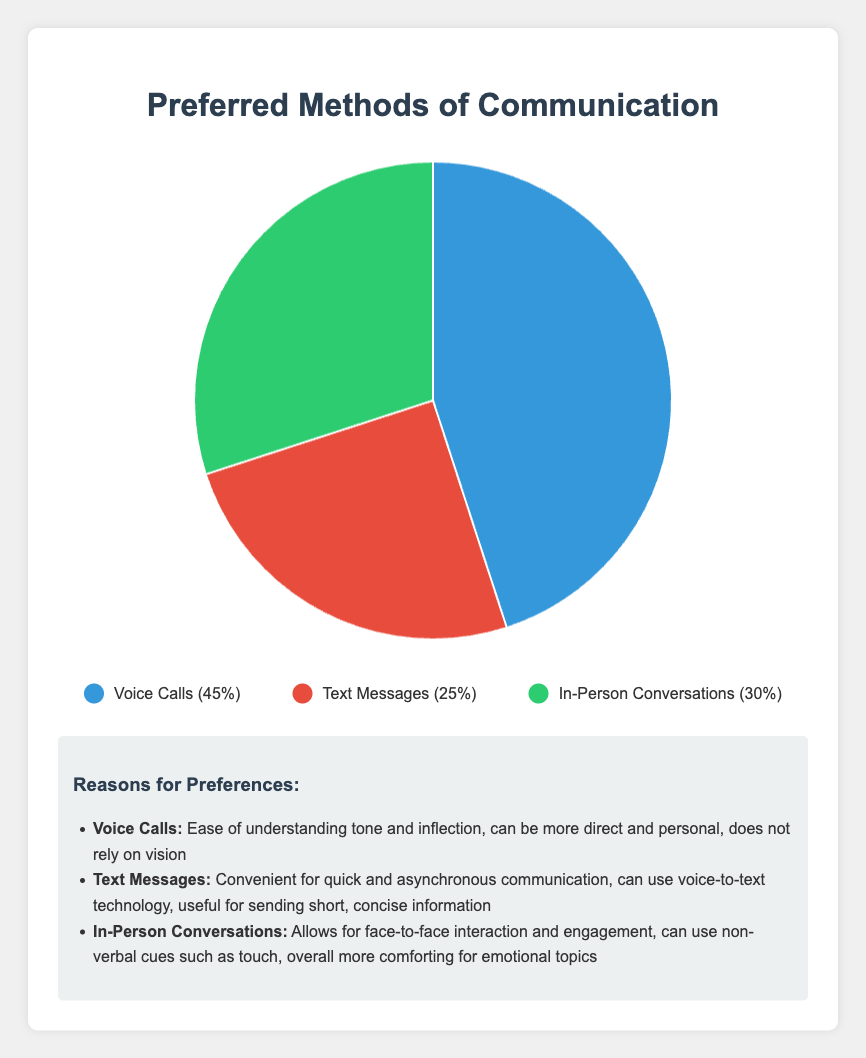What's the largest communication method visualized in the pie chart? The legend and the pie chart show that the method with the largest percentage is Voice Calls at 45%.
Answer: Voice Calls What percentage of people prefer Text Messages compared to those preferring In-Person Conversations? According to the pie chart, 25% prefer Text Messages and 30% prefer In-Person Conversations. Subtracting these gives 30% - 25% = 5%. Hence, 5% more people prefer In-Person Conversations than Text Messages.
Answer: 5% What color represents Voice Calls in the pie chart? The legend in the figure indicates that Voice Calls are represented by blue.
Answer: Blue Combining the two least preferred methods, what is their total percentage? The percentages for Text Messages and In-Person Conversations are 25% and 30%, respectively. Their combined percentage is 25% + 30% = 55%.
Answer: 55% Are Voice Calls preferred at least as much as the combined total of the other two methods? Voice Calls constitute 45% of the preferences. The combined total for Text Messages and In-Person Conversations is 25% + 30% = 55%. So, Voice Calls are not preferred as much as the combined total of Text Messages and In-Person Conversations.
Answer: No Which method has the most direct and personal nature, according to the chart? The list of reasons under the pie chart explains the characteristics of each method. Voice Calls are noted to be more direct and personal.
Answer: Voice Calls If 200 people were surveyed, how many of them prefer Voice Calls? Given that 45% prefer Voice Calls, multiplying 45% by 200 results in 0.45 * 200 = 90 people.
Answer: 90 Which non-visual feature is emphasized for Text Messages? The reasons listed highlight that Text Messages can use voice-to-text technology, which is a non-visual feature.
Answer: Voice-to-text technology How much more popular are In-Person Conversations compared to Text Messages? In-Person Conversations have a preference of 30%, while Text Messages have 25%. The difference is 30% - 25% = 5%.
Answer: 5% 